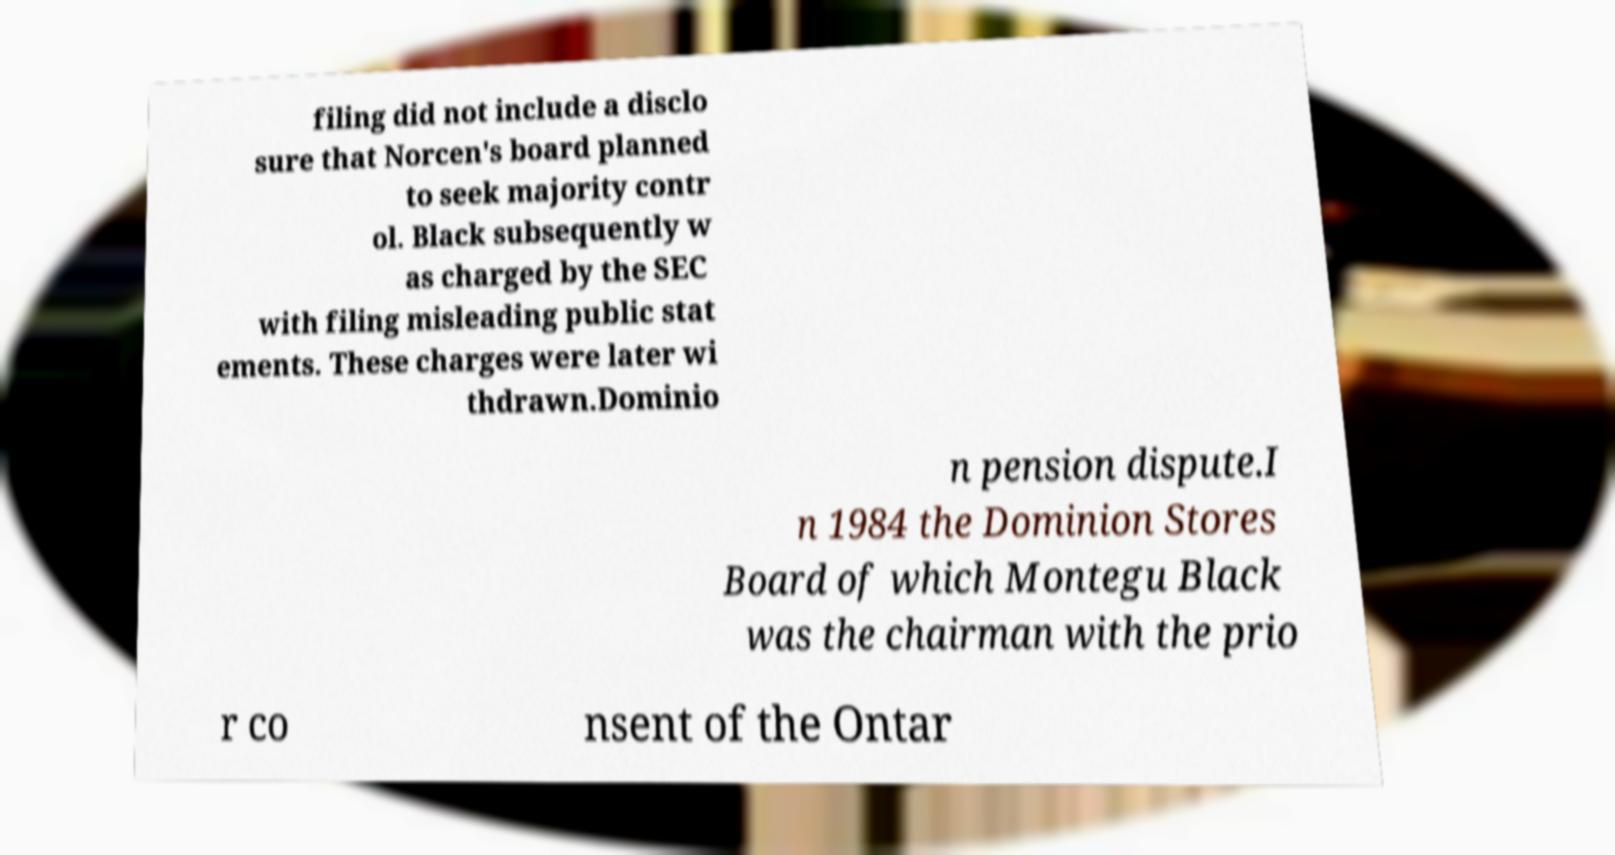Can you read and provide the text displayed in the image?This photo seems to have some interesting text. Can you extract and type it out for me? filing did not include a disclo sure that Norcen's board planned to seek majority contr ol. Black subsequently w as charged by the SEC with filing misleading public stat ements. These charges were later wi thdrawn.Dominio n pension dispute.I n 1984 the Dominion Stores Board of which Montegu Black was the chairman with the prio r co nsent of the Ontar 